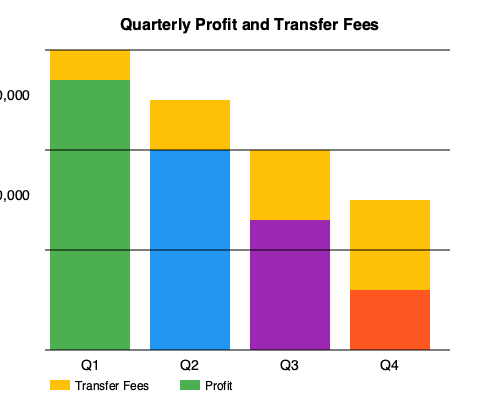Based on the stacked bar chart showing quarterly profit and transfer fees for an Australian import business, calculate the percentage of total revenue lost to transfer fees in Q4, assuming that total revenue is the sum of profit and transfer fees. To solve this problem, we need to follow these steps:

1. Identify the profit and transfer fees for Q4:
   - Profit (orange bar): 150 units
   - Transfer fees (yellow bar): 90 units

2. Calculate the total revenue for Q4:
   Total revenue = Profit + Transfer fees
   $= 150 + 90 = 240$ units

3. Calculate the percentage of revenue lost to transfer fees:
   Percentage = (Transfer fees / Total revenue) × 100
   $= (90 / 240) × 100$
   $= 0.375 × 100$
   $= 37.5\%$

Therefore, in Q4, 37.5% of the total revenue was lost to transfer fees.
Answer: 37.5% 